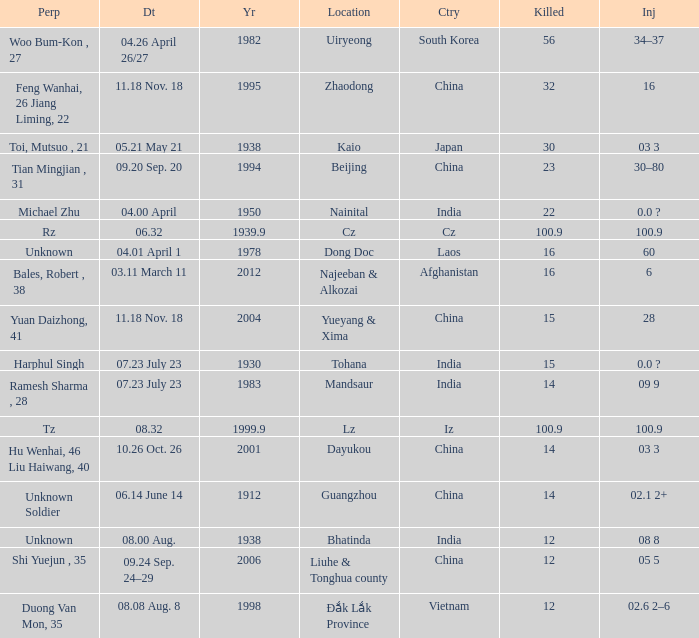01 april 1"? 1978.0. 